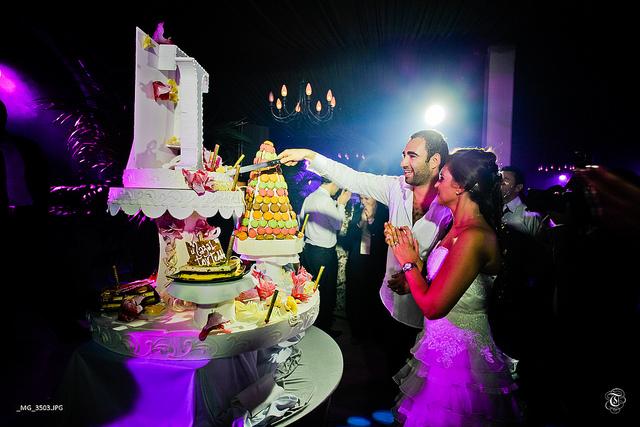Is the man with the knife clean shaven?
Write a very short answer. No. What color is the woman's dress?
Concise answer only. White. What are they celebrating?
Give a very brief answer. Wedding. 